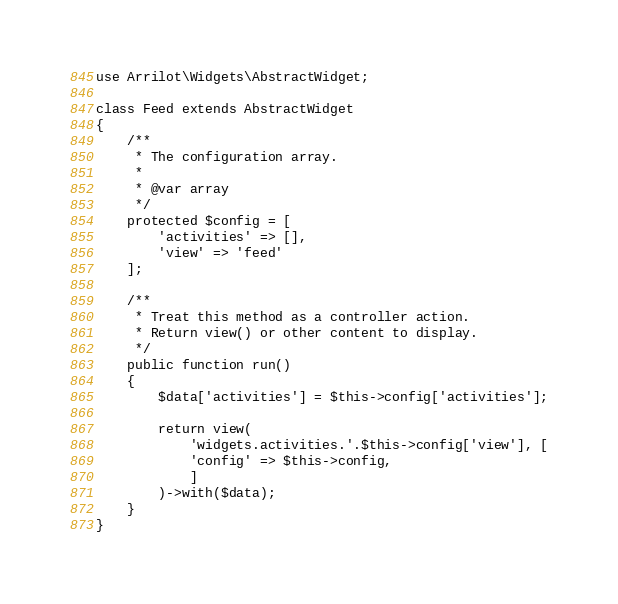<code> <loc_0><loc_0><loc_500><loc_500><_PHP_>
use Arrilot\Widgets\AbstractWidget;

class Feed extends AbstractWidget
{
    /**
     * The configuration array.
     *
     * @var array
     */
    protected $config = [
        'activities' => [],
        'view' => 'feed'
    ];

    /**
     * Treat this method as a controller action.
     * Return view() or other content to display.
     */
    public function run()
    {
        $data['activities'] = $this->config['activities'];

        return view(
            'widgets.activities.'.$this->config['view'], [
            'config' => $this->config,
            ]
        )->with($data);
    }
}
</code> 